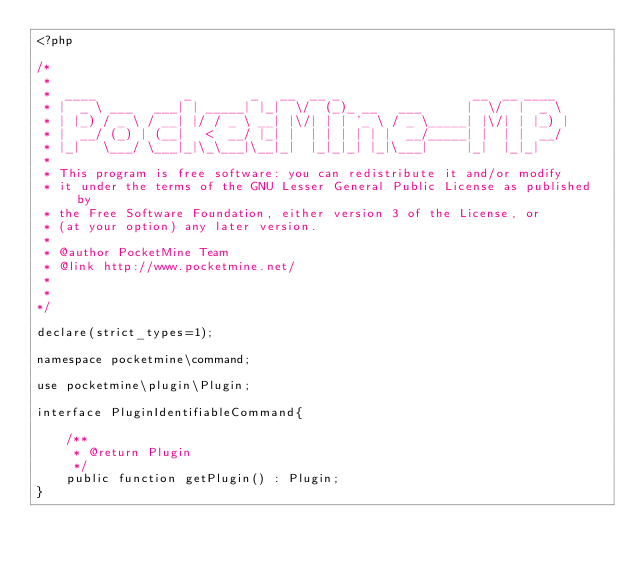<code> <loc_0><loc_0><loc_500><loc_500><_PHP_><?php

/*
 *
 *  ____            _        _   __  __ _                  __  __ ____
 * |  _ \ ___   ___| | _____| |_|  \/  (_)_ __   ___      |  \/  |  _ \
 * | |_) / _ \ / __| |/ / _ \ __| |\/| | | '_ \ / _ \_____| |\/| | |_) |
 * |  __/ (_) | (__|   <  __/ |_| |  | | | | | |  __/_____| |  | |  __/
 * |_|   \___/ \___|_|\_\___|\__|_|  |_|_|_| |_|\___|     |_|  |_|_|
 *
 * This program is free software: you can redistribute it and/or modify
 * it under the terms of the GNU Lesser General Public License as published by
 * the Free Software Foundation, either version 3 of the License, or
 * (at your option) any later version.
 *
 * @author PocketMine Team
 * @link http://www.pocketmine.net/
 *
 *
*/

declare(strict_types=1);

namespace pocketmine\command;

use pocketmine\plugin\Plugin;

interface PluginIdentifiableCommand{

	/**
	 * @return Plugin
	 */
	public function getPlugin() : Plugin;
}
</code> 